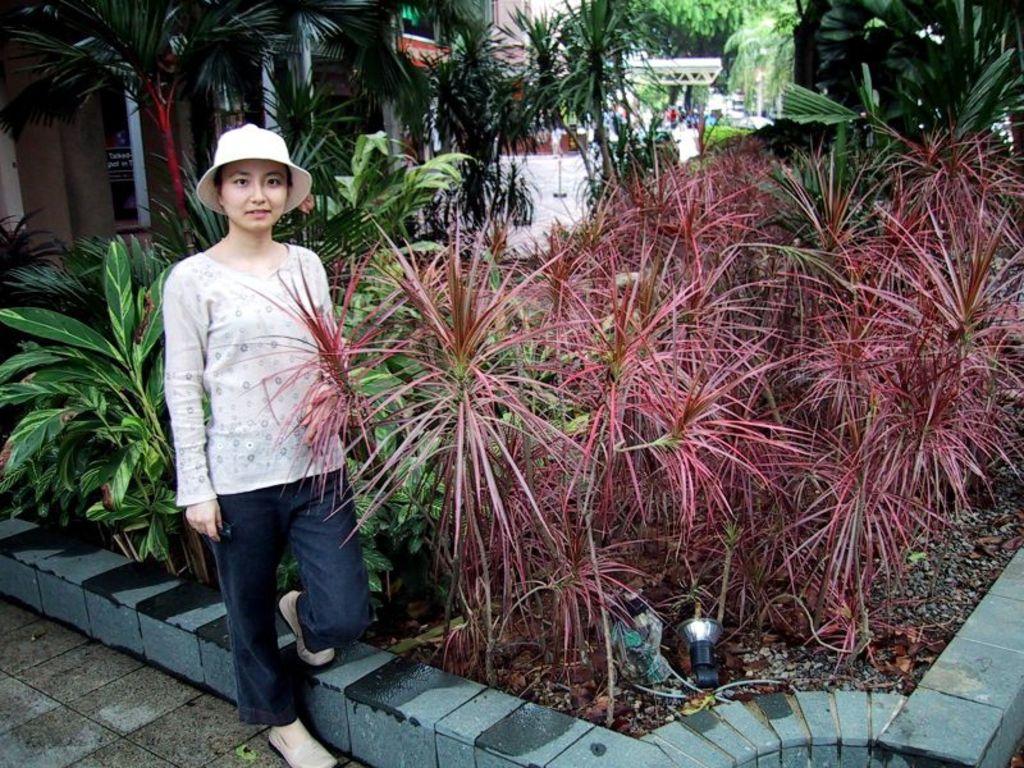In one or two sentences, can you explain what this image depicts? In this picture we can see a woman is standing, she wore a cap, in the background there is a building, there are some plants in the front, in the background we can see some trees. 